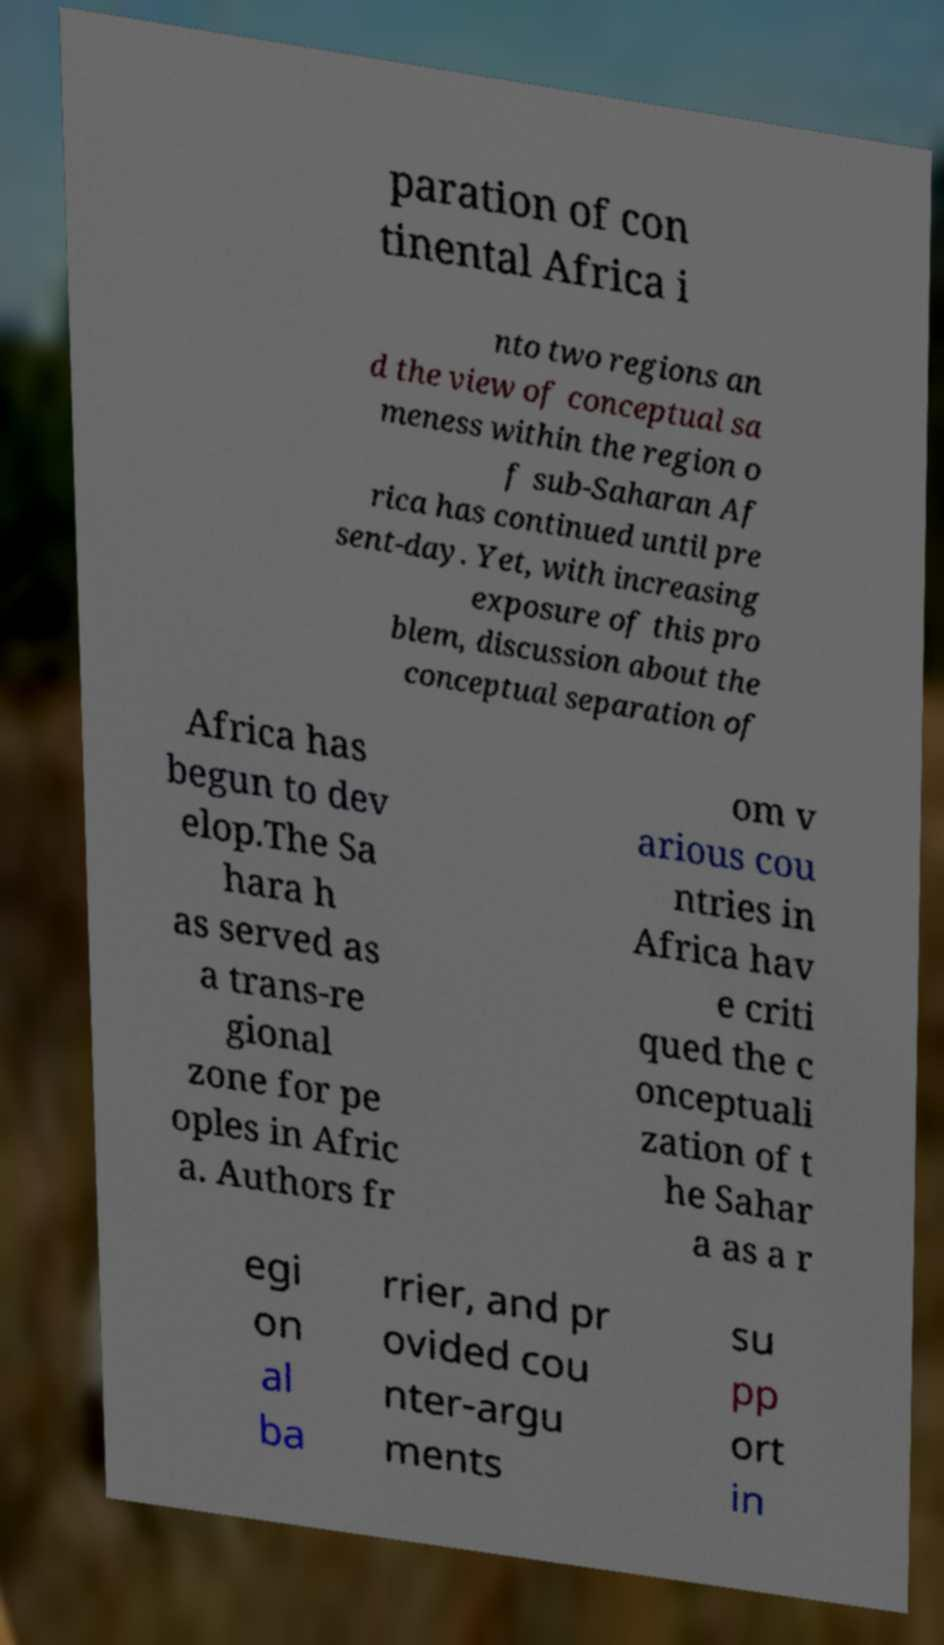Can you read and provide the text displayed in the image?This photo seems to have some interesting text. Can you extract and type it out for me? paration of con tinental Africa i nto two regions an d the view of conceptual sa meness within the region o f sub-Saharan Af rica has continued until pre sent-day. Yet, with increasing exposure of this pro blem, discussion about the conceptual separation of Africa has begun to dev elop.The Sa hara h as served as a trans-re gional zone for pe oples in Afric a. Authors fr om v arious cou ntries in Africa hav e criti qued the c onceptuali zation of t he Sahar a as a r egi on al ba rrier, and pr ovided cou nter-argu ments su pp ort in 